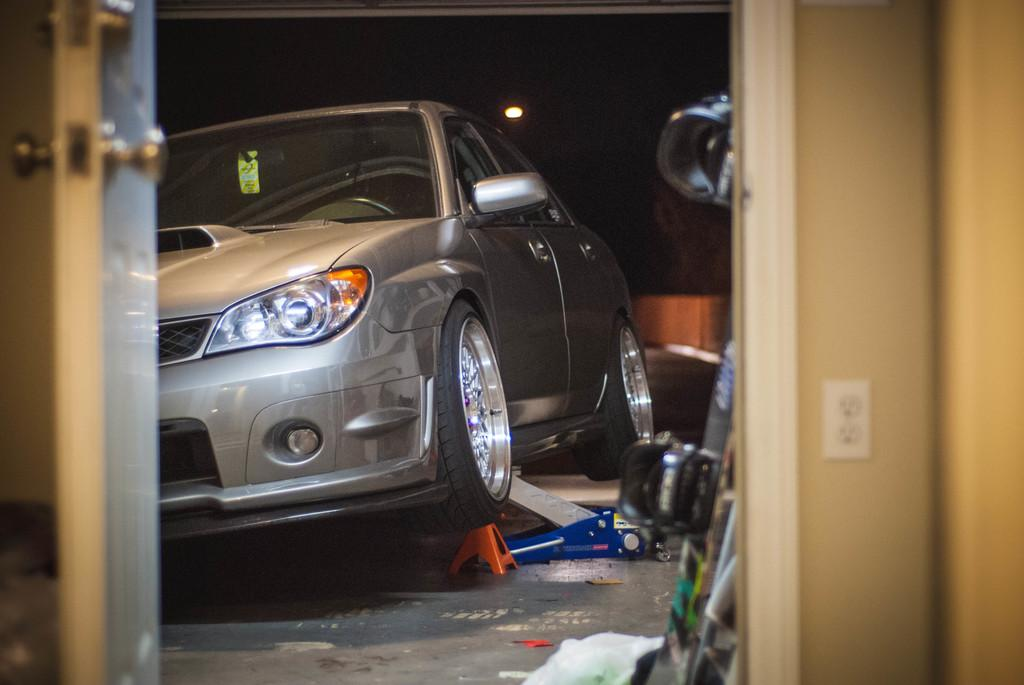What is located in the foreground of the image? There is a door in the foreground of the image. What is present behind the door? There is a wall in the image. What can be seen in the background of the image? There is a car in the background of the image. What is on the floor at the bottom of the image? There are objects on the floor at the bottom of the image. What type of theory is being discussed in the image? There is no discussion or indication of a theory in the image. Can you tell me how many cans of soda are visible in the image? There is no soda present in the image. 